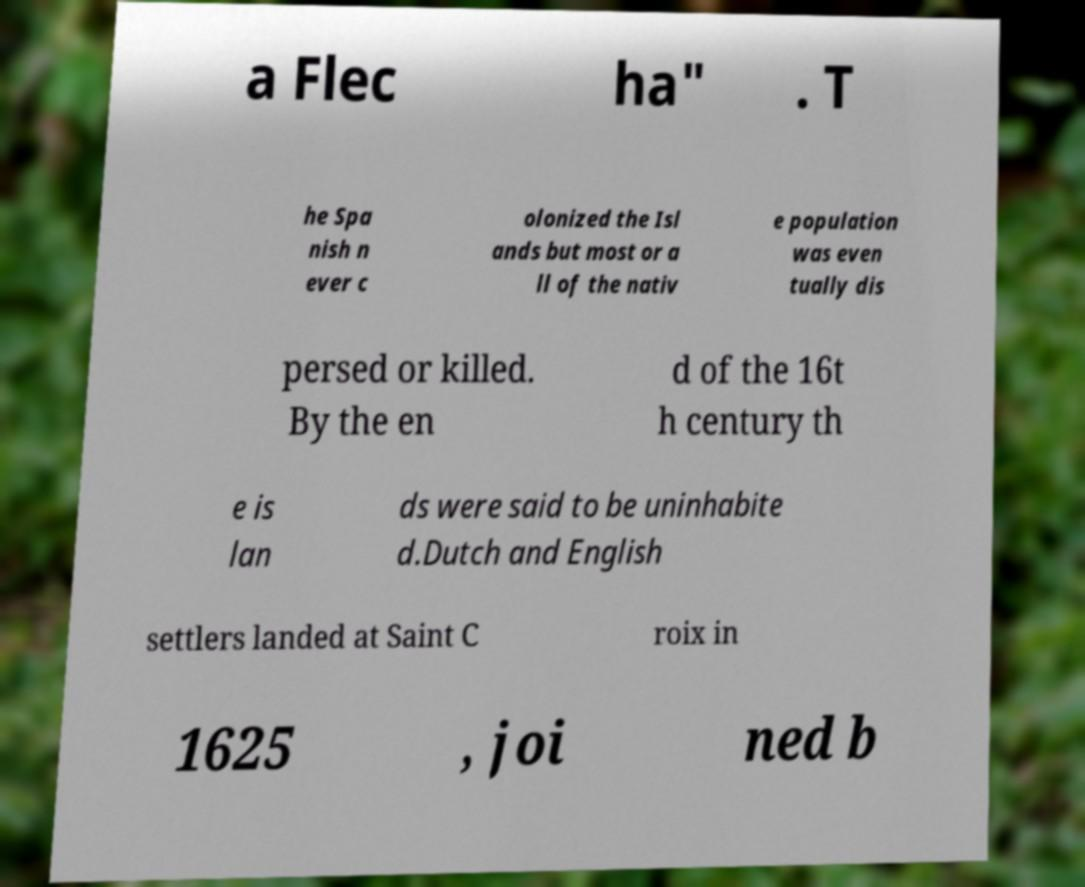Could you extract and type out the text from this image? a Flec ha" . T he Spa nish n ever c olonized the Isl ands but most or a ll of the nativ e population was even tually dis persed or killed. By the en d of the 16t h century th e is lan ds were said to be uninhabite d.Dutch and English settlers landed at Saint C roix in 1625 , joi ned b 